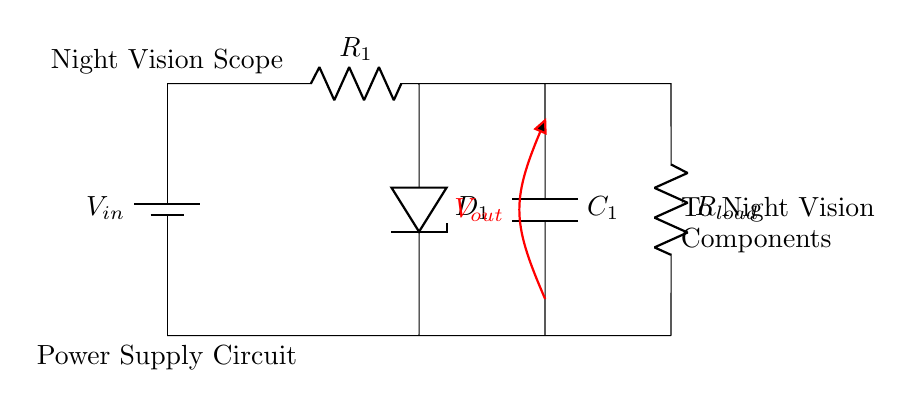What is the input voltage of this circuit? The input voltage is denoted by the label V sub in at the battery component. It's typically the voltage provided to the circuit as a power source.
Answer: V in What type of voltage regulation device is used in this circuit? The device used for voltage regulation is labeled as D sub 1 in the circuit diagram, which indicates a zener diode functioning to regulate voltage.
Answer: zener diode What is the purpose of capacitor C sub 1? Capacitor C sub 1 is used to smooth the output voltage by filtering out fluctuations, ensuring a stable voltage supply to the load.
Answer: smoothing What is the load resistor labeled in the circuit? The load resistor is indicated as R sub load in the circuit, representing the resistance that the night vision scope would draw from the circuit.
Answer: R load How many main components are directly in series with the input voltage? Analyzing the circuit, R sub 1, D sub 1, and C sub 1 are components in series that the input voltage passes through before reaching the load. Thus, there are three components in series.
Answer: 3 What is the output voltage location indicated by the diagram? The output voltage is indicated as V sub out, which is marked at the output of capacitor C sub 1 and before the load resistor, showing where the regulated voltage is available.
Answer: V out Explain the function of resistor R sub 1 in this circuit setting. Resistor R sub 1 limits the current flowing into the zener diode D sub 1, thereby protecting it from excessive current and aiding in maintaining proper voltage regulation across the load.
Answer: current limiting 